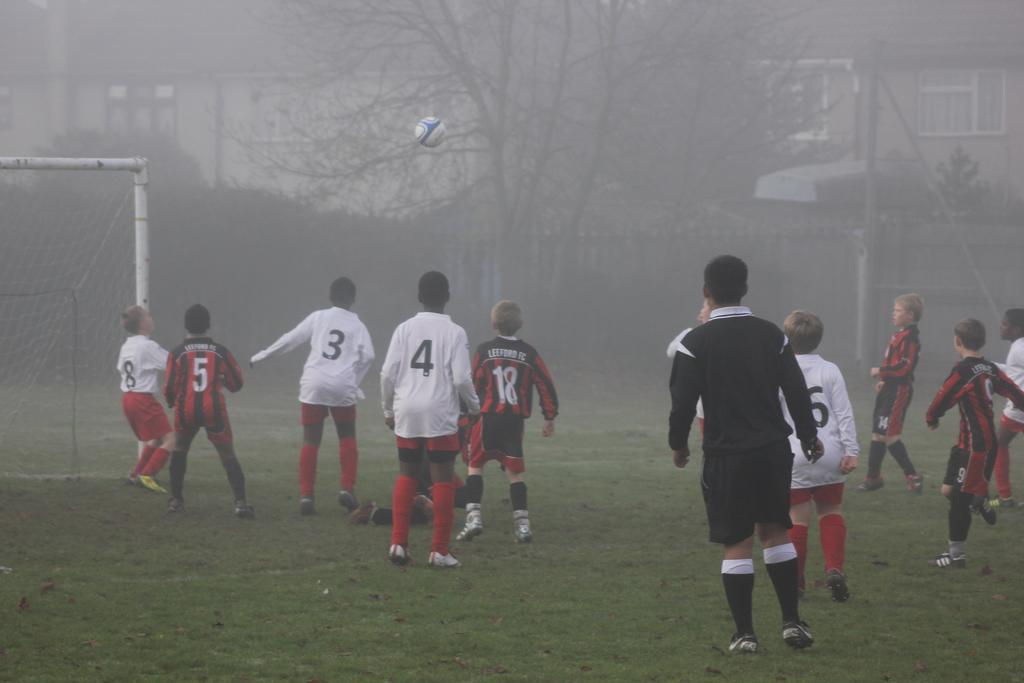<image>
Offer a succinct explanation of the picture presented. A youth soccer game with two teams; one of them being Leeford FC. 